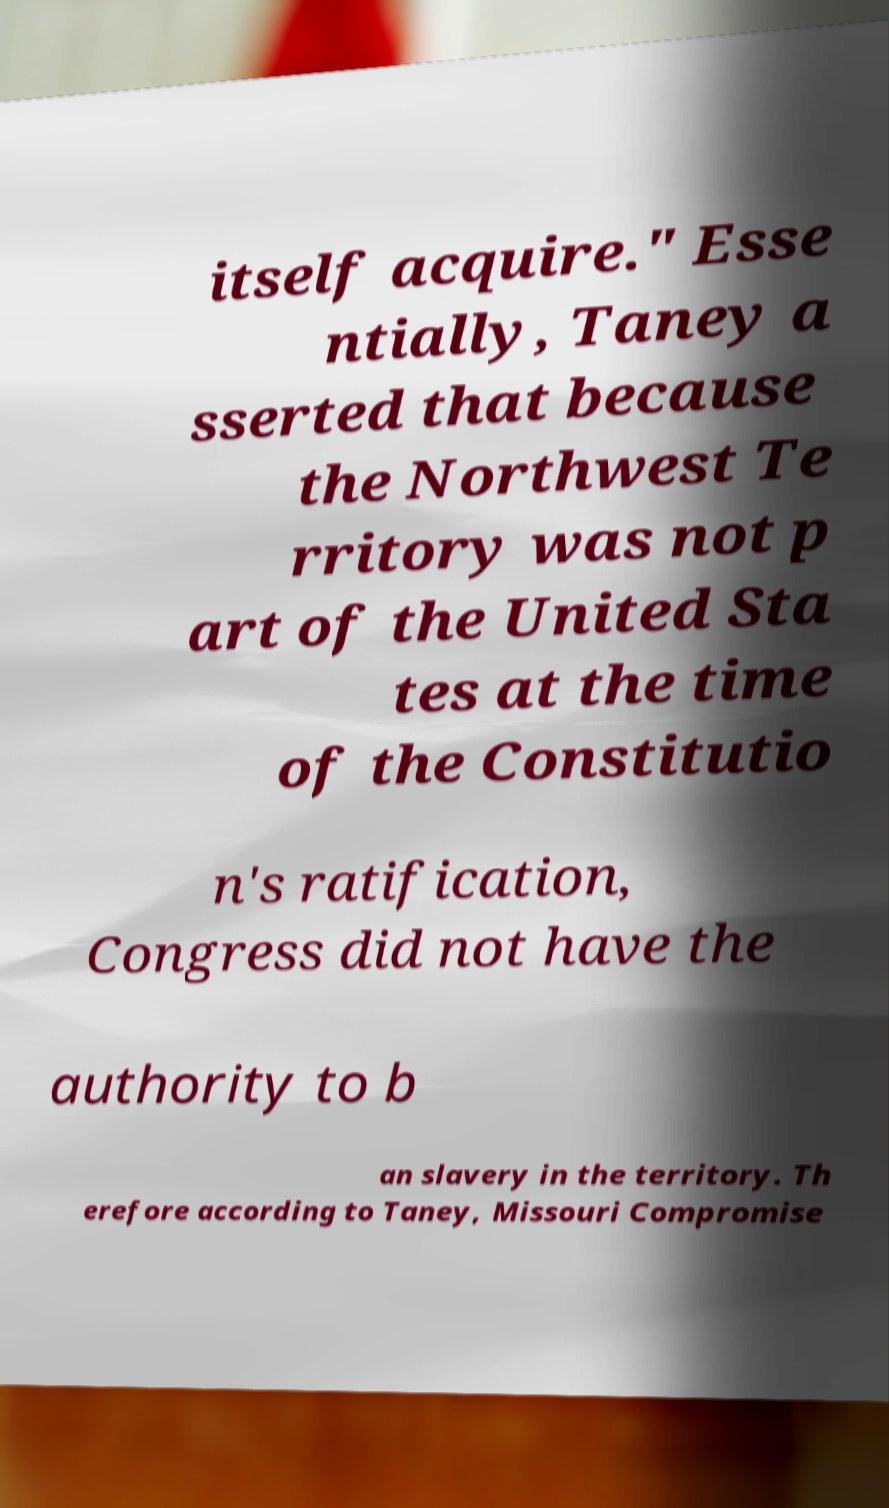Can you accurately transcribe the text from the provided image for me? itself acquire." Esse ntially, Taney a sserted that because the Northwest Te rritory was not p art of the United Sta tes at the time of the Constitutio n's ratification, Congress did not have the authority to b an slavery in the territory. Th erefore according to Taney, Missouri Compromise 